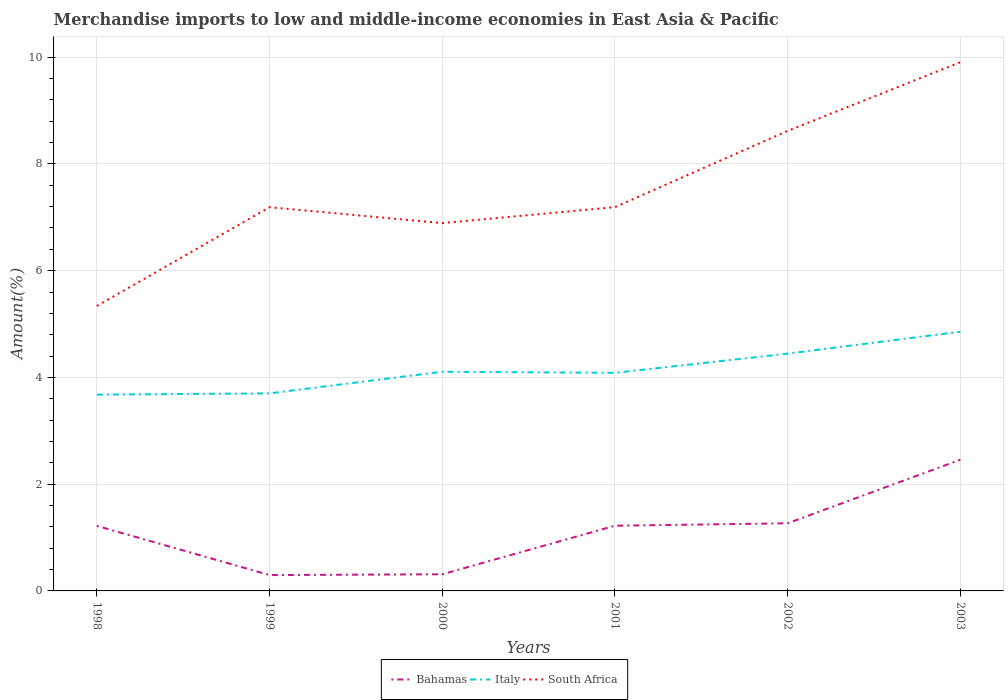Is the number of lines equal to the number of legend labels?
Ensure brevity in your answer.  Yes. Across all years, what is the maximum percentage of amount earned from merchandise imports in Italy?
Your response must be concise. 3.68. In which year was the percentage of amount earned from merchandise imports in South Africa maximum?
Your answer should be compact. 1998. What is the total percentage of amount earned from merchandise imports in South Africa in the graph?
Make the answer very short. -4.57. What is the difference between the highest and the second highest percentage of amount earned from merchandise imports in Italy?
Provide a short and direct response. 1.18. Is the percentage of amount earned from merchandise imports in Italy strictly greater than the percentage of amount earned from merchandise imports in Bahamas over the years?
Offer a very short reply. No. Does the graph contain any zero values?
Your answer should be very brief. No. Where does the legend appear in the graph?
Your answer should be very brief. Bottom center. How many legend labels are there?
Offer a very short reply. 3. How are the legend labels stacked?
Provide a succinct answer. Horizontal. What is the title of the graph?
Offer a very short reply. Merchandise imports to low and middle-income economies in East Asia & Pacific. What is the label or title of the X-axis?
Keep it short and to the point. Years. What is the label or title of the Y-axis?
Your answer should be very brief. Amount(%). What is the Amount(%) of Bahamas in 1998?
Ensure brevity in your answer.  1.22. What is the Amount(%) of Italy in 1998?
Provide a succinct answer. 3.68. What is the Amount(%) in South Africa in 1998?
Provide a succinct answer. 5.34. What is the Amount(%) of Bahamas in 1999?
Offer a terse response. 0.3. What is the Amount(%) in Italy in 1999?
Provide a succinct answer. 3.7. What is the Amount(%) in South Africa in 1999?
Give a very brief answer. 7.19. What is the Amount(%) of Bahamas in 2000?
Make the answer very short. 0.31. What is the Amount(%) in Italy in 2000?
Make the answer very short. 4.11. What is the Amount(%) of South Africa in 2000?
Your answer should be compact. 6.89. What is the Amount(%) of Bahamas in 2001?
Make the answer very short. 1.22. What is the Amount(%) in Italy in 2001?
Your answer should be very brief. 4.09. What is the Amount(%) of South Africa in 2001?
Ensure brevity in your answer.  7.19. What is the Amount(%) in Bahamas in 2002?
Make the answer very short. 1.27. What is the Amount(%) in Italy in 2002?
Your response must be concise. 4.45. What is the Amount(%) in South Africa in 2002?
Offer a terse response. 8.62. What is the Amount(%) of Bahamas in 2003?
Offer a terse response. 2.46. What is the Amount(%) in Italy in 2003?
Provide a short and direct response. 4.86. What is the Amount(%) in South Africa in 2003?
Offer a very short reply. 9.91. Across all years, what is the maximum Amount(%) of Bahamas?
Your response must be concise. 2.46. Across all years, what is the maximum Amount(%) of Italy?
Ensure brevity in your answer.  4.86. Across all years, what is the maximum Amount(%) of South Africa?
Your answer should be compact. 9.91. Across all years, what is the minimum Amount(%) in Bahamas?
Keep it short and to the point. 0.3. Across all years, what is the minimum Amount(%) in Italy?
Provide a succinct answer. 3.68. Across all years, what is the minimum Amount(%) of South Africa?
Ensure brevity in your answer.  5.34. What is the total Amount(%) in Bahamas in the graph?
Make the answer very short. 6.77. What is the total Amount(%) in Italy in the graph?
Your answer should be compact. 24.87. What is the total Amount(%) of South Africa in the graph?
Your answer should be compact. 45.14. What is the difference between the Amount(%) of Bahamas in 1998 and that in 1999?
Offer a very short reply. 0.92. What is the difference between the Amount(%) in Italy in 1998 and that in 1999?
Provide a short and direct response. -0.02. What is the difference between the Amount(%) of South Africa in 1998 and that in 1999?
Provide a succinct answer. -1.85. What is the difference between the Amount(%) in Bahamas in 1998 and that in 2000?
Offer a terse response. 0.91. What is the difference between the Amount(%) in Italy in 1998 and that in 2000?
Give a very brief answer. -0.43. What is the difference between the Amount(%) of South Africa in 1998 and that in 2000?
Make the answer very short. -1.55. What is the difference between the Amount(%) in Bahamas in 1998 and that in 2001?
Keep it short and to the point. -0. What is the difference between the Amount(%) of Italy in 1998 and that in 2001?
Your answer should be very brief. -0.41. What is the difference between the Amount(%) of South Africa in 1998 and that in 2001?
Keep it short and to the point. -1.85. What is the difference between the Amount(%) of Bahamas in 1998 and that in 2002?
Your answer should be compact. -0.05. What is the difference between the Amount(%) in Italy in 1998 and that in 2002?
Provide a succinct answer. -0.77. What is the difference between the Amount(%) in South Africa in 1998 and that in 2002?
Your response must be concise. -3.28. What is the difference between the Amount(%) of Bahamas in 1998 and that in 2003?
Give a very brief answer. -1.24. What is the difference between the Amount(%) in Italy in 1998 and that in 2003?
Give a very brief answer. -1.18. What is the difference between the Amount(%) of South Africa in 1998 and that in 2003?
Your answer should be very brief. -4.57. What is the difference between the Amount(%) of Bahamas in 1999 and that in 2000?
Give a very brief answer. -0.01. What is the difference between the Amount(%) in Italy in 1999 and that in 2000?
Provide a succinct answer. -0.41. What is the difference between the Amount(%) in South Africa in 1999 and that in 2000?
Your answer should be very brief. 0.3. What is the difference between the Amount(%) in Bahamas in 1999 and that in 2001?
Provide a short and direct response. -0.92. What is the difference between the Amount(%) in Italy in 1999 and that in 2001?
Your answer should be very brief. -0.38. What is the difference between the Amount(%) in South Africa in 1999 and that in 2001?
Offer a very short reply. -0. What is the difference between the Amount(%) in Bahamas in 1999 and that in 2002?
Ensure brevity in your answer.  -0.97. What is the difference between the Amount(%) in Italy in 1999 and that in 2002?
Offer a very short reply. -0.74. What is the difference between the Amount(%) of South Africa in 1999 and that in 2002?
Your answer should be compact. -1.43. What is the difference between the Amount(%) of Bahamas in 1999 and that in 2003?
Provide a short and direct response. -2.16. What is the difference between the Amount(%) of Italy in 1999 and that in 2003?
Offer a terse response. -1.15. What is the difference between the Amount(%) of South Africa in 1999 and that in 2003?
Offer a terse response. -2.72. What is the difference between the Amount(%) of Bahamas in 2000 and that in 2001?
Provide a succinct answer. -0.91. What is the difference between the Amount(%) in Italy in 2000 and that in 2001?
Provide a short and direct response. 0.02. What is the difference between the Amount(%) in South Africa in 2000 and that in 2001?
Offer a terse response. -0.3. What is the difference between the Amount(%) in Bahamas in 2000 and that in 2002?
Offer a very short reply. -0.96. What is the difference between the Amount(%) of Italy in 2000 and that in 2002?
Offer a terse response. -0.34. What is the difference between the Amount(%) of South Africa in 2000 and that in 2002?
Give a very brief answer. -1.73. What is the difference between the Amount(%) in Bahamas in 2000 and that in 2003?
Offer a very short reply. -2.15. What is the difference between the Amount(%) of Italy in 2000 and that in 2003?
Ensure brevity in your answer.  -0.75. What is the difference between the Amount(%) in South Africa in 2000 and that in 2003?
Your answer should be compact. -3.01. What is the difference between the Amount(%) in Bahamas in 2001 and that in 2002?
Your answer should be very brief. -0.05. What is the difference between the Amount(%) in Italy in 2001 and that in 2002?
Your answer should be compact. -0.36. What is the difference between the Amount(%) of South Africa in 2001 and that in 2002?
Provide a succinct answer. -1.43. What is the difference between the Amount(%) in Bahamas in 2001 and that in 2003?
Ensure brevity in your answer.  -1.24. What is the difference between the Amount(%) in Italy in 2001 and that in 2003?
Offer a terse response. -0.77. What is the difference between the Amount(%) in South Africa in 2001 and that in 2003?
Provide a succinct answer. -2.72. What is the difference between the Amount(%) in Bahamas in 2002 and that in 2003?
Your response must be concise. -1.19. What is the difference between the Amount(%) in Italy in 2002 and that in 2003?
Your response must be concise. -0.41. What is the difference between the Amount(%) of South Africa in 2002 and that in 2003?
Your response must be concise. -1.29. What is the difference between the Amount(%) of Bahamas in 1998 and the Amount(%) of Italy in 1999?
Your response must be concise. -2.48. What is the difference between the Amount(%) of Bahamas in 1998 and the Amount(%) of South Africa in 1999?
Provide a succinct answer. -5.97. What is the difference between the Amount(%) of Italy in 1998 and the Amount(%) of South Africa in 1999?
Your answer should be compact. -3.51. What is the difference between the Amount(%) of Bahamas in 1998 and the Amount(%) of Italy in 2000?
Provide a short and direct response. -2.89. What is the difference between the Amount(%) in Bahamas in 1998 and the Amount(%) in South Africa in 2000?
Offer a very short reply. -5.67. What is the difference between the Amount(%) in Italy in 1998 and the Amount(%) in South Africa in 2000?
Provide a succinct answer. -3.21. What is the difference between the Amount(%) in Bahamas in 1998 and the Amount(%) in Italy in 2001?
Ensure brevity in your answer.  -2.87. What is the difference between the Amount(%) in Bahamas in 1998 and the Amount(%) in South Africa in 2001?
Ensure brevity in your answer.  -5.97. What is the difference between the Amount(%) of Italy in 1998 and the Amount(%) of South Africa in 2001?
Keep it short and to the point. -3.51. What is the difference between the Amount(%) in Bahamas in 1998 and the Amount(%) in Italy in 2002?
Offer a terse response. -3.23. What is the difference between the Amount(%) of Bahamas in 1998 and the Amount(%) of South Africa in 2002?
Your answer should be very brief. -7.4. What is the difference between the Amount(%) in Italy in 1998 and the Amount(%) in South Africa in 2002?
Keep it short and to the point. -4.94. What is the difference between the Amount(%) of Bahamas in 1998 and the Amount(%) of Italy in 2003?
Your answer should be very brief. -3.64. What is the difference between the Amount(%) of Bahamas in 1998 and the Amount(%) of South Africa in 2003?
Make the answer very short. -8.69. What is the difference between the Amount(%) in Italy in 1998 and the Amount(%) in South Africa in 2003?
Your response must be concise. -6.23. What is the difference between the Amount(%) of Bahamas in 1999 and the Amount(%) of Italy in 2000?
Make the answer very short. -3.81. What is the difference between the Amount(%) in Bahamas in 1999 and the Amount(%) in South Africa in 2000?
Keep it short and to the point. -6.59. What is the difference between the Amount(%) of Italy in 1999 and the Amount(%) of South Africa in 2000?
Offer a very short reply. -3.19. What is the difference between the Amount(%) in Bahamas in 1999 and the Amount(%) in Italy in 2001?
Your answer should be very brief. -3.79. What is the difference between the Amount(%) of Bahamas in 1999 and the Amount(%) of South Africa in 2001?
Provide a short and direct response. -6.89. What is the difference between the Amount(%) in Italy in 1999 and the Amount(%) in South Africa in 2001?
Your answer should be very brief. -3.49. What is the difference between the Amount(%) of Bahamas in 1999 and the Amount(%) of Italy in 2002?
Provide a succinct answer. -4.15. What is the difference between the Amount(%) of Bahamas in 1999 and the Amount(%) of South Africa in 2002?
Provide a short and direct response. -8.32. What is the difference between the Amount(%) in Italy in 1999 and the Amount(%) in South Africa in 2002?
Ensure brevity in your answer.  -4.92. What is the difference between the Amount(%) of Bahamas in 1999 and the Amount(%) of Italy in 2003?
Give a very brief answer. -4.56. What is the difference between the Amount(%) in Bahamas in 1999 and the Amount(%) in South Africa in 2003?
Offer a very short reply. -9.61. What is the difference between the Amount(%) of Italy in 1999 and the Amount(%) of South Africa in 2003?
Your response must be concise. -6.2. What is the difference between the Amount(%) in Bahamas in 2000 and the Amount(%) in Italy in 2001?
Provide a short and direct response. -3.77. What is the difference between the Amount(%) in Bahamas in 2000 and the Amount(%) in South Africa in 2001?
Ensure brevity in your answer.  -6.88. What is the difference between the Amount(%) of Italy in 2000 and the Amount(%) of South Africa in 2001?
Keep it short and to the point. -3.08. What is the difference between the Amount(%) of Bahamas in 2000 and the Amount(%) of Italy in 2002?
Keep it short and to the point. -4.13. What is the difference between the Amount(%) in Bahamas in 2000 and the Amount(%) in South Africa in 2002?
Offer a very short reply. -8.31. What is the difference between the Amount(%) of Italy in 2000 and the Amount(%) of South Africa in 2002?
Your answer should be very brief. -4.51. What is the difference between the Amount(%) of Bahamas in 2000 and the Amount(%) of Italy in 2003?
Provide a short and direct response. -4.54. What is the difference between the Amount(%) in Bahamas in 2000 and the Amount(%) in South Africa in 2003?
Your answer should be compact. -9.59. What is the difference between the Amount(%) in Italy in 2000 and the Amount(%) in South Africa in 2003?
Your answer should be compact. -5.8. What is the difference between the Amount(%) of Bahamas in 2001 and the Amount(%) of Italy in 2002?
Your response must be concise. -3.22. What is the difference between the Amount(%) in Bahamas in 2001 and the Amount(%) in South Africa in 2002?
Give a very brief answer. -7.4. What is the difference between the Amount(%) of Italy in 2001 and the Amount(%) of South Africa in 2002?
Provide a succinct answer. -4.53. What is the difference between the Amount(%) of Bahamas in 2001 and the Amount(%) of Italy in 2003?
Your response must be concise. -3.64. What is the difference between the Amount(%) in Bahamas in 2001 and the Amount(%) in South Africa in 2003?
Offer a very short reply. -8.68. What is the difference between the Amount(%) of Italy in 2001 and the Amount(%) of South Africa in 2003?
Ensure brevity in your answer.  -5.82. What is the difference between the Amount(%) of Bahamas in 2002 and the Amount(%) of Italy in 2003?
Keep it short and to the point. -3.59. What is the difference between the Amount(%) of Bahamas in 2002 and the Amount(%) of South Africa in 2003?
Your response must be concise. -8.64. What is the difference between the Amount(%) of Italy in 2002 and the Amount(%) of South Africa in 2003?
Provide a short and direct response. -5.46. What is the average Amount(%) in Bahamas per year?
Offer a terse response. 1.13. What is the average Amount(%) in Italy per year?
Give a very brief answer. 4.15. What is the average Amount(%) in South Africa per year?
Keep it short and to the point. 7.52. In the year 1998, what is the difference between the Amount(%) of Bahamas and Amount(%) of Italy?
Provide a short and direct response. -2.46. In the year 1998, what is the difference between the Amount(%) of Bahamas and Amount(%) of South Africa?
Make the answer very short. -4.12. In the year 1998, what is the difference between the Amount(%) of Italy and Amount(%) of South Africa?
Give a very brief answer. -1.66. In the year 1999, what is the difference between the Amount(%) in Bahamas and Amount(%) in Italy?
Give a very brief answer. -3.4. In the year 1999, what is the difference between the Amount(%) of Bahamas and Amount(%) of South Africa?
Your answer should be very brief. -6.89. In the year 1999, what is the difference between the Amount(%) in Italy and Amount(%) in South Africa?
Your answer should be very brief. -3.49. In the year 2000, what is the difference between the Amount(%) of Bahamas and Amount(%) of Italy?
Provide a short and direct response. -3.79. In the year 2000, what is the difference between the Amount(%) in Bahamas and Amount(%) in South Africa?
Make the answer very short. -6.58. In the year 2000, what is the difference between the Amount(%) in Italy and Amount(%) in South Africa?
Your response must be concise. -2.79. In the year 2001, what is the difference between the Amount(%) in Bahamas and Amount(%) in Italy?
Give a very brief answer. -2.86. In the year 2001, what is the difference between the Amount(%) in Bahamas and Amount(%) in South Africa?
Make the answer very short. -5.97. In the year 2001, what is the difference between the Amount(%) of Italy and Amount(%) of South Africa?
Your answer should be compact. -3.1. In the year 2002, what is the difference between the Amount(%) in Bahamas and Amount(%) in Italy?
Provide a succinct answer. -3.18. In the year 2002, what is the difference between the Amount(%) in Bahamas and Amount(%) in South Africa?
Give a very brief answer. -7.35. In the year 2002, what is the difference between the Amount(%) of Italy and Amount(%) of South Africa?
Your answer should be compact. -4.17. In the year 2003, what is the difference between the Amount(%) of Bahamas and Amount(%) of Italy?
Keep it short and to the point. -2.4. In the year 2003, what is the difference between the Amount(%) in Bahamas and Amount(%) in South Africa?
Your answer should be very brief. -7.45. In the year 2003, what is the difference between the Amount(%) in Italy and Amount(%) in South Africa?
Your response must be concise. -5.05. What is the ratio of the Amount(%) of Bahamas in 1998 to that in 1999?
Provide a succinct answer. 4.1. What is the ratio of the Amount(%) in South Africa in 1998 to that in 1999?
Offer a terse response. 0.74. What is the ratio of the Amount(%) of Bahamas in 1998 to that in 2000?
Your answer should be very brief. 3.91. What is the ratio of the Amount(%) of Italy in 1998 to that in 2000?
Your answer should be compact. 0.9. What is the ratio of the Amount(%) in South Africa in 1998 to that in 2000?
Give a very brief answer. 0.77. What is the ratio of the Amount(%) of Italy in 1998 to that in 2001?
Your response must be concise. 0.9. What is the ratio of the Amount(%) in South Africa in 1998 to that in 2001?
Your response must be concise. 0.74. What is the ratio of the Amount(%) in Bahamas in 1998 to that in 2002?
Ensure brevity in your answer.  0.96. What is the ratio of the Amount(%) in Italy in 1998 to that in 2002?
Offer a terse response. 0.83. What is the ratio of the Amount(%) of South Africa in 1998 to that in 2002?
Provide a short and direct response. 0.62. What is the ratio of the Amount(%) in Bahamas in 1998 to that in 2003?
Provide a short and direct response. 0.5. What is the ratio of the Amount(%) in Italy in 1998 to that in 2003?
Keep it short and to the point. 0.76. What is the ratio of the Amount(%) in South Africa in 1998 to that in 2003?
Provide a short and direct response. 0.54. What is the ratio of the Amount(%) in Bahamas in 1999 to that in 2000?
Provide a succinct answer. 0.95. What is the ratio of the Amount(%) of Italy in 1999 to that in 2000?
Provide a short and direct response. 0.9. What is the ratio of the Amount(%) in South Africa in 1999 to that in 2000?
Give a very brief answer. 1.04. What is the ratio of the Amount(%) in Bahamas in 1999 to that in 2001?
Give a very brief answer. 0.24. What is the ratio of the Amount(%) in Italy in 1999 to that in 2001?
Your answer should be compact. 0.91. What is the ratio of the Amount(%) in South Africa in 1999 to that in 2001?
Offer a very short reply. 1. What is the ratio of the Amount(%) of Bahamas in 1999 to that in 2002?
Provide a succinct answer. 0.23. What is the ratio of the Amount(%) of Italy in 1999 to that in 2002?
Give a very brief answer. 0.83. What is the ratio of the Amount(%) of South Africa in 1999 to that in 2002?
Make the answer very short. 0.83. What is the ratio of the Amount(%) of Bahamas in 1999 to that in 2003?
Provide a short and direct response. 0.12. What is the ratio of the Amount(%) in Italy in 1999 to that in 2003?
Offer a very short reply. 0.76. What is the ratio of the Amount(%) of South Africa in 1999 to that in 2003?
Keep it short and to the point. 0.73. What is the ratio of the Amount(%) in Bahamas in 2000 to that in 2001?
Provide a succinct answer. 0.26. What is the ratio of the Amount(%) in Italy in 2000 to that in 2001?
Your response must be concise. 1. What is the ratio of the Amount(%) in South Africa in 2000 to that in 2001?
Offer a terse response. 0.96. What is the ratio of the Amount(%) in Bahamas in 2000 to that in 2002?
Your answer should be very brief. 0.25. What is the ratio of the Amount(%) of Italy in 2000 to that in 2002?
Your answer should be very brief. 0.92. What is the ratio of the Amount(%) of South Africa in 2000 to that in 2002?
Keep it short and to the point. 0.8. What is the ratio of the Amount(%) in Bahamas in 2000 to that in 2003?
Your answer should be very brief. 0.13. What is the ratio of the Amount(%) of Italy in 2000 to that in 2003?
Your answer should be very brief. 0.85. What is the ratio of the Amount(%) of South Africa in 2000 to that in 2003?
Offer a very short reply. 0.7. What is the ratio of the Amount(%) in Bahamas in 2001 to that in 2002?
Give a very brief answer. 0.96. What is the ratio of the Amount(%) of Italy in 2001 to that in 2002?
Your answer should be compact. 0.92. What is the ratio of the Amount(%) of South Africa in 2001 to that in 2002?
Offer a terse response. 0.83. What is the ratio of the Amount(%) in Bahamas in 2001 to that in 2003?
Provide a succinct answer. 0.5. What is the ratio of the Amount(%) of Italy in 2001 to that in 2003?
Your answer should be very brief. 0.84. What is the ratio of the Amount(%) of South Africa in 2001 to that in 2003?
Offer a very short reply. 0.73. What is the ratio of the Amount(%) in Bahamas in 2002 to that in 2003?
Provide a short and direct response. 0.52. What is the ratio of the Amount(%) of Italy in 2002 to that in 2003?
Provide a short and direct response. 0.92. What is the ratio of the Amount(%) of South Africa in 2002 to that in 2003?
Make the answer very short. 0.87. What is the difference between the highest and the second highest Amount(%) of Bahamas?
Provide a succinct answer. 1.19. What is the difference between the highest and the second highest Amount(%) in Italy?
Your response must be concise. 0.41. What is the difference between the highest and the second highest Amount(%) of South Africa?
Make the answer very short. 1.29. What is the difference between the highest and the lowest Amount(%) of Bahamas?
Provide a succinct answer. 2.16. What is the difference between the highest and the lowest Amount(%) of Italy?
Provide a short and direct response. 1.18. What is the difference between the highest and the lowest Amount(%) in South Africa?
Your answer should be very brief. 4.57. 